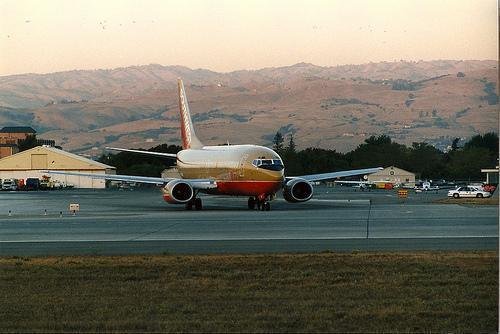How many engines does the nearest plane have?
Give a very brief answer. 2. 